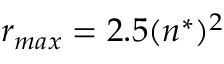<formula> <loc_0><loc_0><loc_500><loc_500>r _ { \max } = 2 . 5 ( n ^ { * } ) ^ { 2 }</formula> 